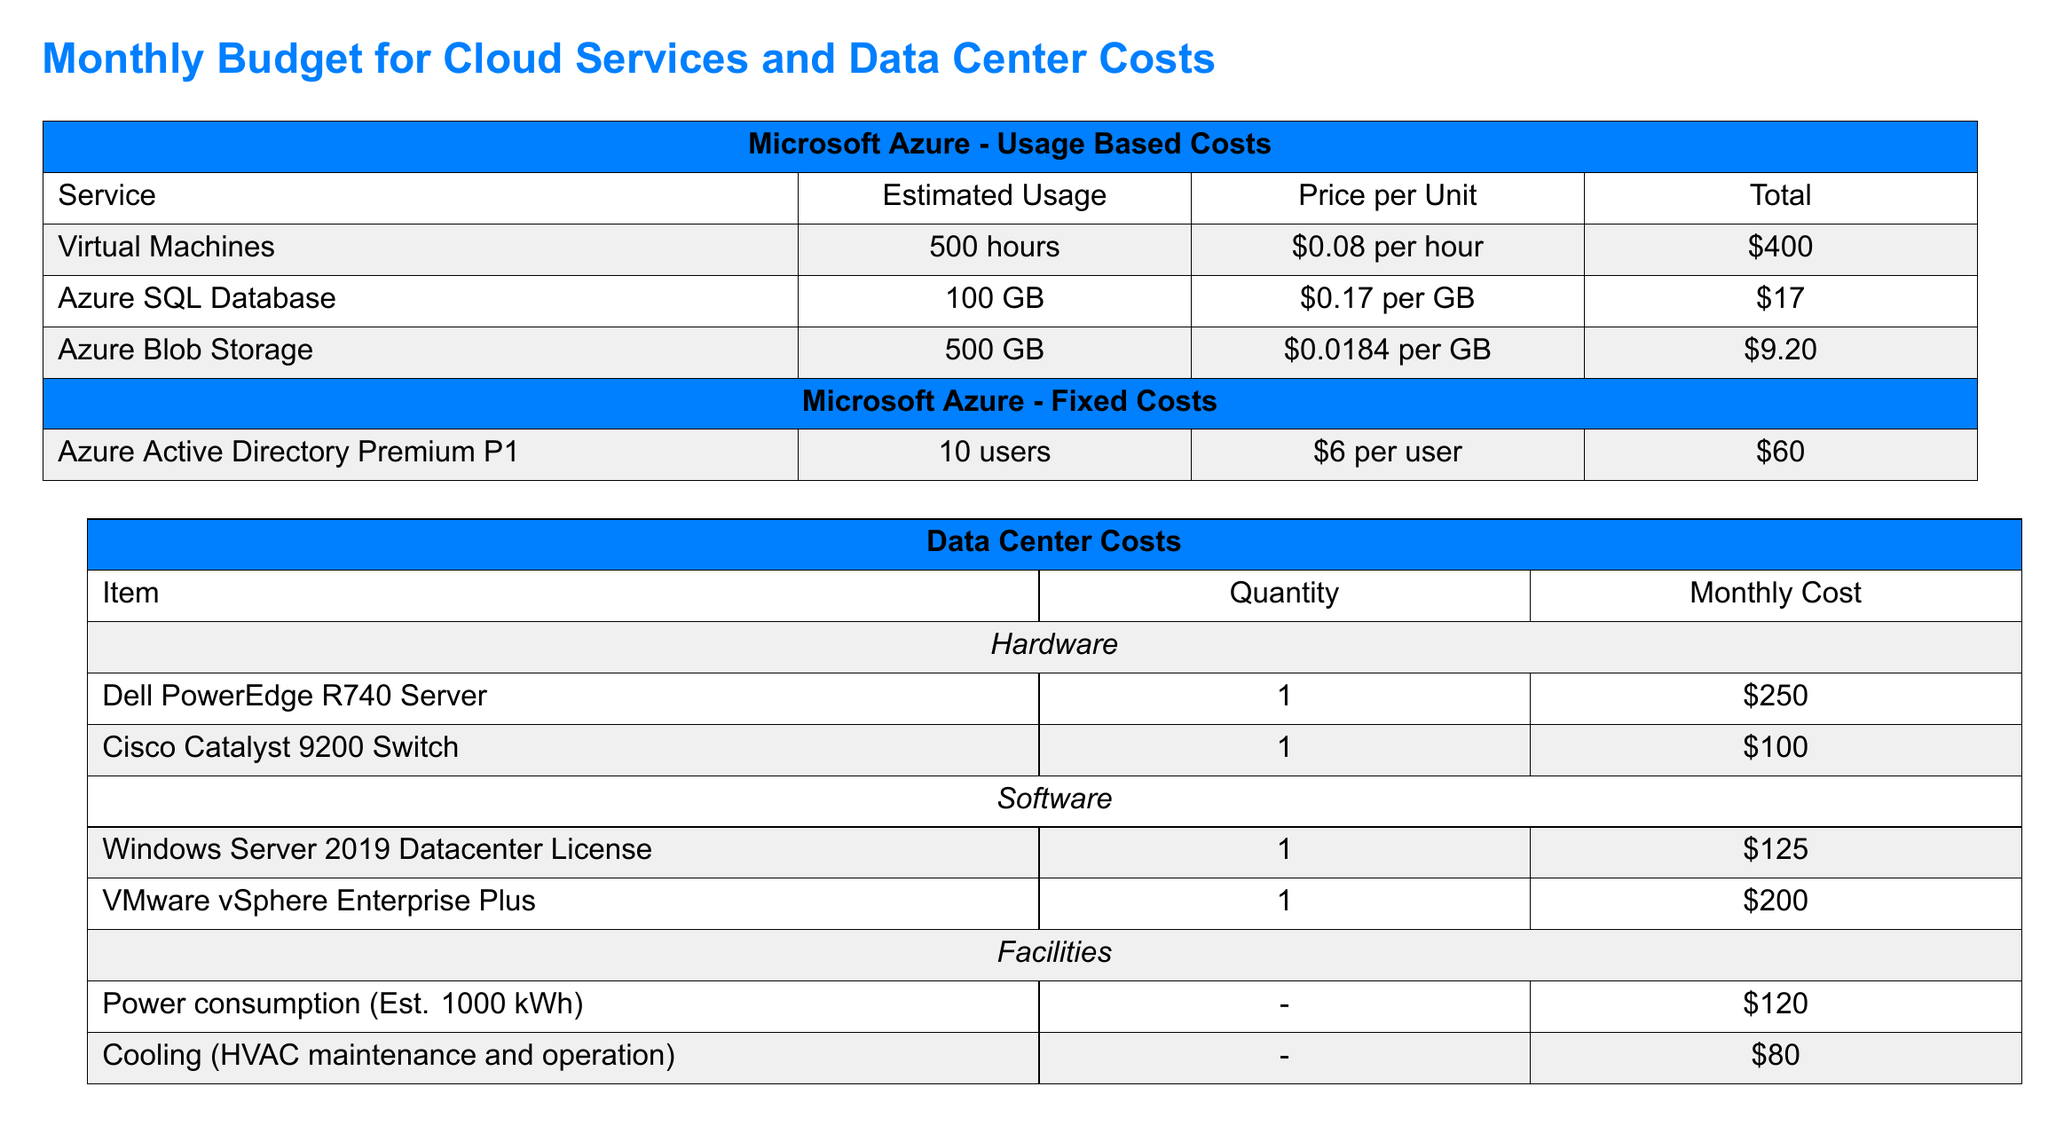What is the total cost for Virtual Machines? The total cost for Virtual Machines is calculated as 500 hours multiplied by $0.08 per hour, which equals $400.
Answer: $400 How much does Azure Active Directory Premium P1 cost per user? The cost per user for Azure Active Directory Premium P1 is listed in the fixed costs section as $6 per user.
Answer: $6 What is the monthly cost for Cisco Catalyst 9200 Switch? The monthly cost for a Cisco Catalyst 9200 Switch appears in the data center costs section as $100.
Answer: $100 What is the estimated usage for Azure SQL Database? The estimated usage for Azure SQL Database is 100 GB, stated in the usage based costs section.
Answer: 100 GB What is the total amount for Data Center Costs? The document states the total amount for Data Center Costs as $875.00, which includes multiple hardware and software components.
Answer: $875.00 How much do Azure Integration Services cost in total? The total cost for Integration Services, which includes Azure ExpressRoute and Azure Site Recovery, sums to $450.
Answer: $450 How much is the total monthly cost for all categories? The total monthly cost for all categories is provided at the end of the budget document, totaling $1,811.20.
Answer: $1,811.20 What amount does power consumption estimate for the Data Center? The estimated monthly cost for power consumption in the Data Center is listed as $120.
Answer: $120 What is the price per GB for Azure Blob Storage? The price per GB for Azure Blob Storage is indicated in the usage based costs section as $0.0184 per GB.
Answer: $0.0184 per GB 